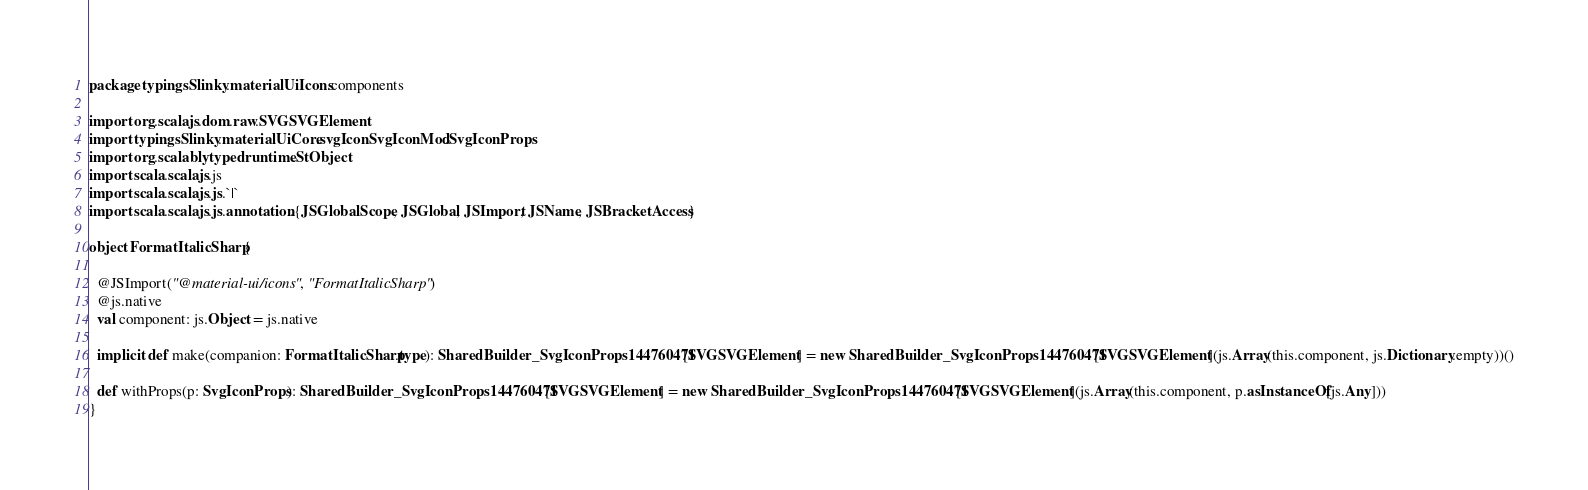<code> <loc_0><loc_0><loc_500><loc_500><_Scala_>package typingsSlinky.materialUiIcons.components

import org.scalajs.dom.raw.SVGSVGElement
import typingsSlinky.materialUiCore.svgIconSvgIconMod.SvgIconProps
import org.scalablytyped.runtime.StObject
import scala.scalajs.js
import scala.scalajs.js.`|`
import scala.scalajs.js.annotation.{JSGlobalScope, JSGlobal, JSImport, JSName, JSBracketAccess}

object FormatItalicSharp {
  
  @JSImport("@material-ui/icons", "FormatItalicSharp")
  @js.native
  val component: js.Object = js.native
  
  implicit def make(companion: FormatItalicSharp.type): SharedBuilder_SvgIconProps144760471[SVGSVGElement] = new SharedBuilder_SvgIconProps144760471[SVGSVGElement](js.Array(this.component, js.Dictionary.empty))()
  
  def withProps(p: SvgIconProps): SharedBuilder_SvgIconProps144760471[SVGSVGElement] = new SharedBuilder_SvgIconProps144760471[SVGSVGElement](js.Array(this.component, p.asInstanceOf[js.Any]))
}
</code> 